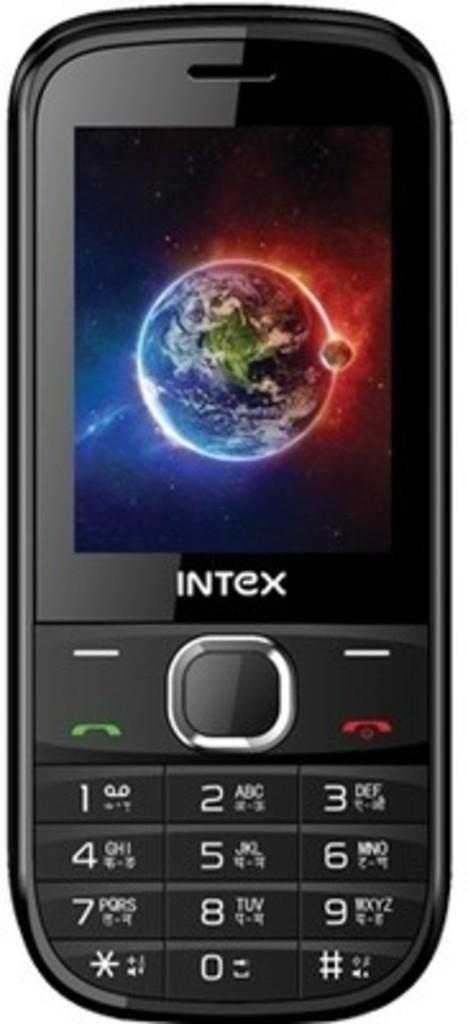<image>
Provide a brief description of the given image. On the screen of an older Intex phone is an image of earth, from space. 